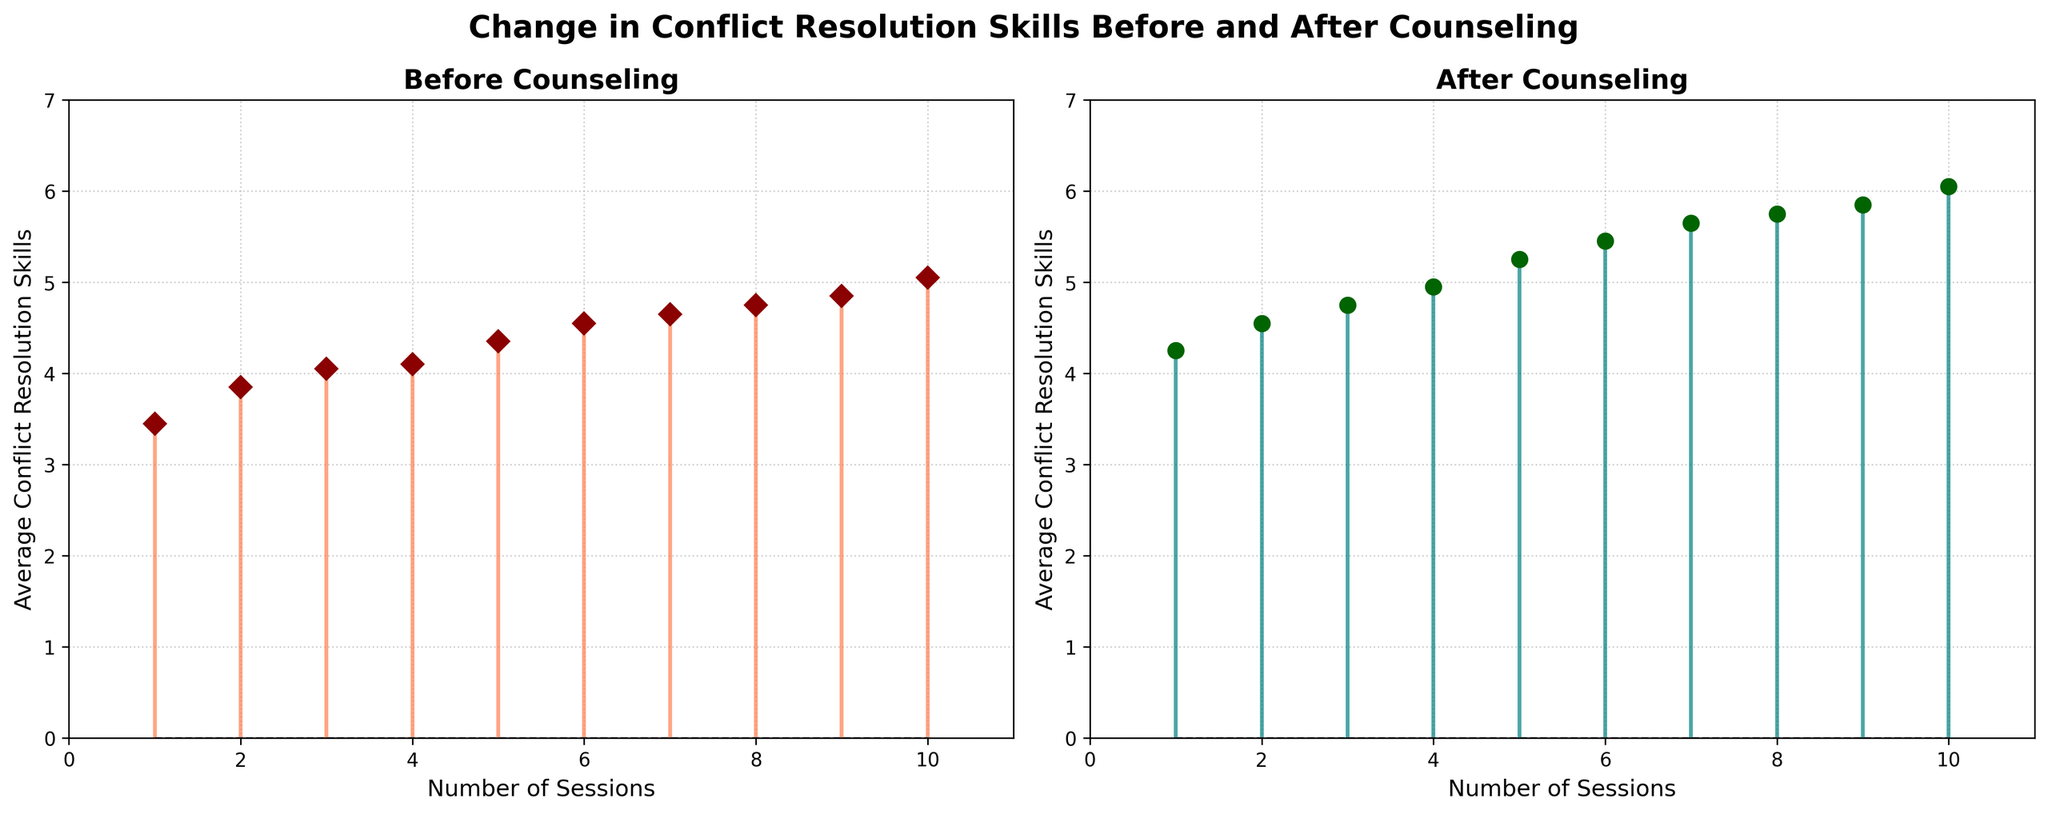What is the title of the figure? The title of the figure is usually placed at the top and is clearly stated to provide a context for the data being shown. In this case, it reads "Change in Conflict Resolution Skills Before and After Counseling".
Answer: Change in Conflict Resolution Skills Before and After Counseling How many subplots are there in the figure? You can see that the figure is split into two separate sections, each with its own data and title. This indicates that there are two subplots.
Answer: 2 What are the colors of the markers before and after counseling? By examining the markers in both subplots, you can observe that the markers before counseling are dark red, and the markers after counseling are dark green.
Answer: Dark red and dark green What is the maximum average conflict resolution skill value after counseling? By observing the y-axis values and identifying the highest marker in the "After Counseling" subplot, you can see that the maximum value is 6.1.
Answer: 6.1 Which subplot has the highest title font size? Both subplots have titles with the same font size, which makes it easy to compare if they are indeed identical.
Answer: Both are the same At how many sessions does the average conflict resolution skill first reach or exceed 5.0 before counseling? Look at the data points in the "Before Counseling" subplot, and identify the session number when the marker reaches or exceeds the value of 5.0. The first occurrence is at session 10.
Answer: 10 What is the difference in average conflict resolution skills before and after counseling at 5 sessions? Locate the data points for 5 sessions in both subplots and subtract the average value of 'Before Counseling' from the 'After Counseling'. The values are 4.4 (before) and 5.3 (after), so the difference is 5.3 - 4.4 = 0.9.
Answer: 0.9 Which session count shows the largest improvement in conflict resolution skills? Calculate the difference between the 'After Counseling' and 'Before Counseling' values for each session and identify the session with the largest difference. Session 10 has the largest improvement (6.1 - 5.1 = 1.0).
Answer: 10 Does the overall trend in conflict resolution skills increase or decrease after counseling as compared to before counseling? Observe the trend lines in both subplots. The “After Counseling” values show a consistently increasing trend as the sessions increase, indicating an improvement.
Answer: Increase How many session counts have an average conflict resolution skill before counseling that is greater than 4.5? By evaluating the data points in the "Before Counseling" subplot, count the number of sessions where the average value exceeds 4.5. Sessions 6, 7, 8, 9, and 10 make up 5 sessions.
Answer: 5 